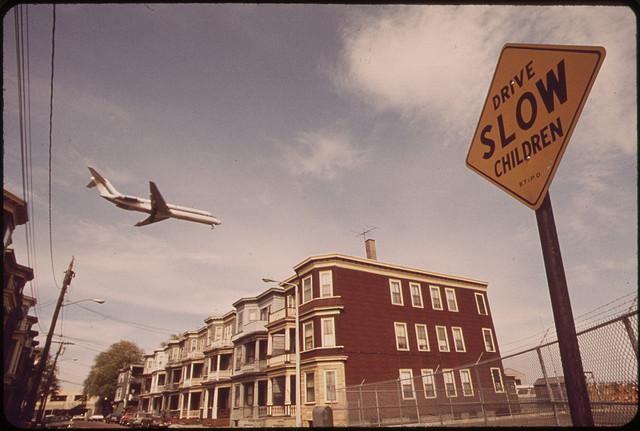Is the sign indicating people should drive using slow children?
Keep it brief. No. What does the sign look like?
Write a very short answer. Diamond. What is the sign saying?
Keep it brief. Drive slow children. What color is the street sign?
Give a very brief answer. Yellow. What color is the sign?
Keep it brief. Yellow. Is it winter in this picture?
Be succinct. No. How many signs are in this picture?
Answer briefly. 1. What color are the letters?
Give a very brief answer. Black. Is this a mountain town?
Short answer required. No. Why is this black and white?
Give a very brief answer. It's not. What color is the building?
Be succinct. Red. What type of sign is this?
Give a very brief answer. Caution. What color are the shutters?
Short answer required. White. What does the sign say?
Answer briefly. Drive slow children. What color is the sky?
Quick response, please. Blue. Is there graffiti on the sign?
Keep it brief. No. What would you do at this sign?
Keep it brief. Slow down. What does the orange sign say?
Quick response, please. Drive slow children. Is this building  tall?
Answer briefly. No. How many porches are there?
Quick response, please. 5. Is parking permitted here?
Be succinct. Yes. 